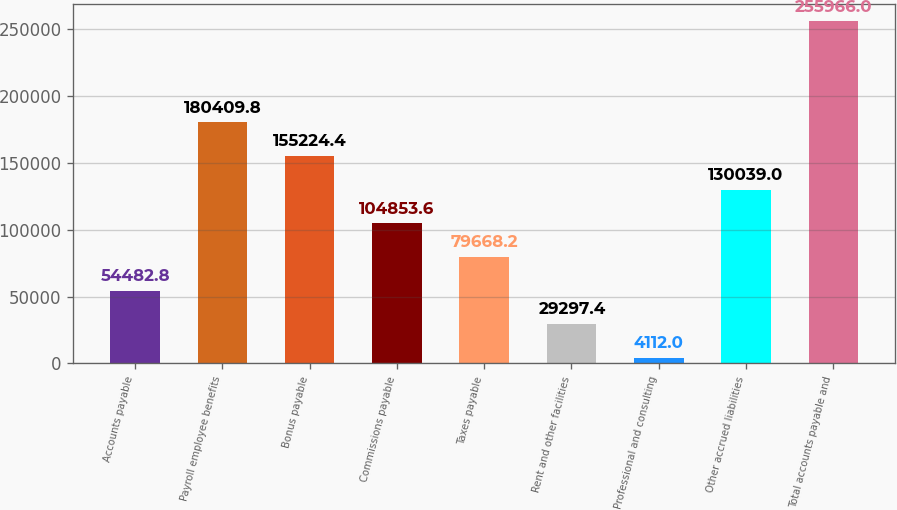Convert chart. <chart><loc_0><loc_0><loc_500><loc_500><bar_chart><fcel>Accounts payable<fcel>Payroll employee benefits<fcel>Bonus payable<fcel>Commissions payable<fcel>Taxes payable<fcel>Rent and other facilities<fcel>Professional and consulting<fcel>Other accrued liabilities<fcel>Total accounts payable and<nl><fcel>54482.8<fcel>180410<fcel>155224<fcel>104854<fcel>79668.2<fcel>29297.4<fcel>4112<fcel>130039<fcel>255966<nl></chart> 